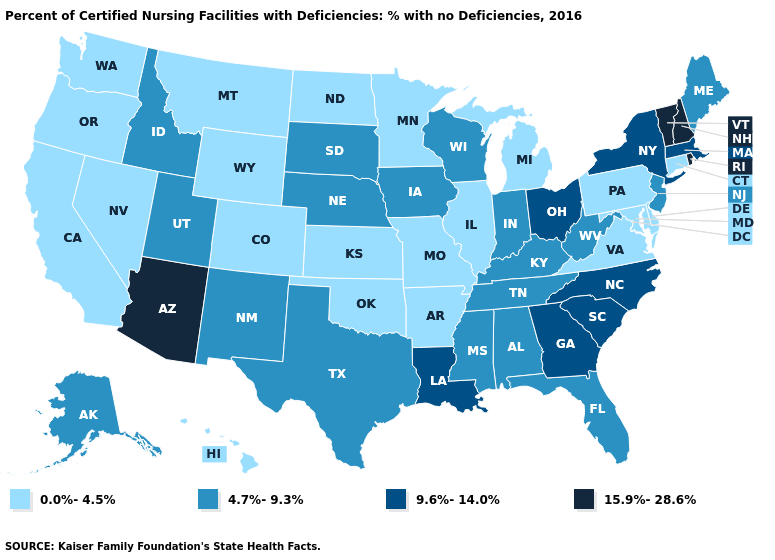Which states have the highest value in the USA?
Concise answer only. Arizona, New Hampshire, Rhode Island, Vermont. Name the states that have a value in the range 0.0%-4.5%?
Short answer required. Arkansas, California, Colorado, Connecticut, Delaware, Hawaii, Illinois, Kansas, Maryland, Michigan, Minnesota, Missouri, Montana, Nevada, North Dakota, Oklahoma, Oregon, Pennsylvania, Virginia, Washington, Wyoming. What is the value of Michigan?
Write a very short answer. 0.0%-4.5%. Name the states that have a value in the range 15.9%-28.6%?
Quick response, please. Arizona, New Hampshire, Rhode Island, Vermont. Name the states that have a value in the range 0.0%-4.5%?
Concise answer only. Arkansas, California, Colorado, Connecticut, Delaware, Hawaii, Illinois, Kansas, Maryland, Michigan, Minnesota, Missouri, Montana, Nevada, North Dakota, Oklahoma, Oregon, Pennsylvania, Virginia, Washington, Wyoming. Does Mississippi have a higher value than Washington?
Answer briefly. Yes. Name the states that have a value in the range 4.7%-9.3%?
Give a very brief answer. Alabama, Alaska, Florida, Idaho, Indiana, Iowa, Kentucky, Maine, Mississippi, Nebraska, New Jersey, New Mexico, South Dakota, Tennessee, Texas, Utah, West Virginia, Wisconsin. Does the first symbol in the legend represent the smallest category?
Short answer required. Yes. Does the first symbol in the legend represent the smallest category?
Keep it brief. Yes. Which states hav the highest value in the West?
Answer briefly. Arizona. Does the map have missing data?
Short answer required. No. What is the value of Utah?
Give a very brief answer. 4.7%-9.3%. Name the states that have a value in the range 0.0%-4.5%?
Keep it brief. Arkansas, California, Colorado, Connecticut, Delaware, Hawaii, Illinois, Kansas, Maryland, Michigan, Minnesota, Missouri, Montana, Nevada, North Dakota, Oklahoma, Oregon, Pennsylvania, Virginia, Washington, Wyoming. What is the value of Maine?
Quick response, please. 4.7%-9.3%. How many symbols are there in the legend?
Short answer required. 4. 